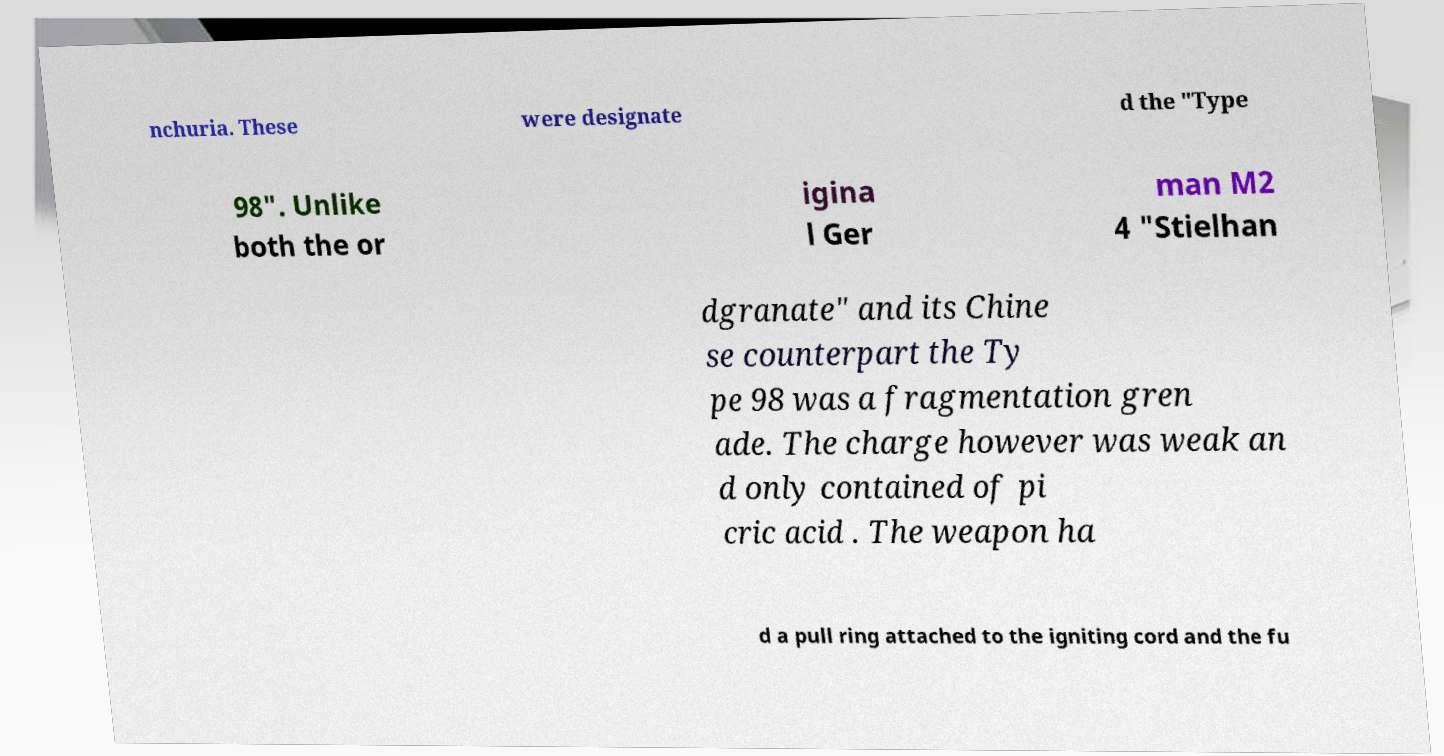Please identify and transcribe the text found in this image. nchuria. These were designate d the "Type 98". Unlike both the or igina l Ger man M2 4 "Stielhan dgranate" and its Chine se counterpart the Ty pe 98 was a fragmentation gren ade. The charge however was weak an d only contained of pi cric acid . The weapon ha d a pull ring attached to the igniting cord and the fu 